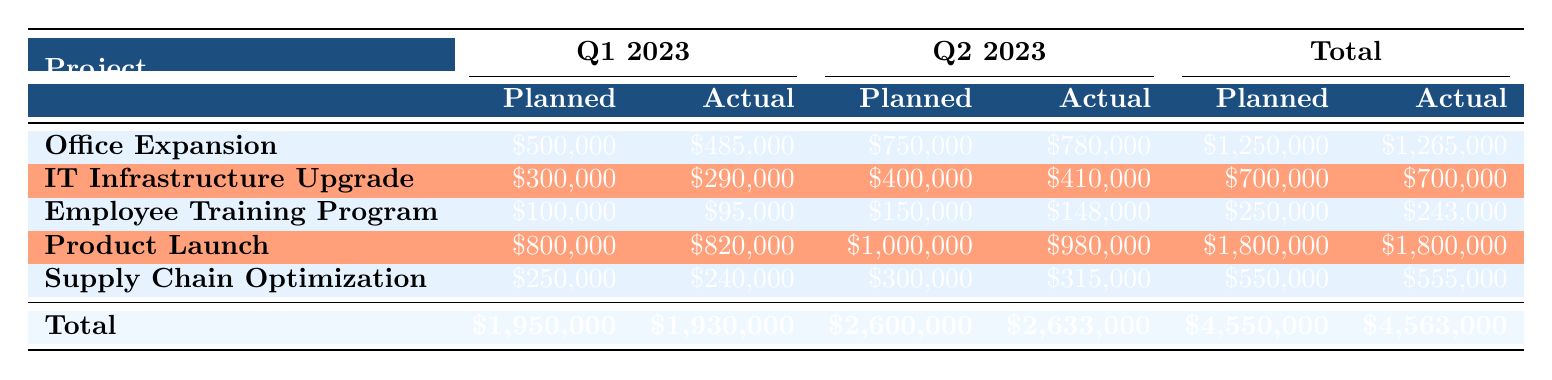What is the planned budget for the Employee Training Program in Q2 2023? The table shows the planned budget for the Employee Training Program in Q2 2023 listed under that project’s row for the respective quarter, which is 150000.
Answer: 150000 What is the actual spend for the IT Infrastructure Upgrade project in Q1 2023? The actual spend for the IT Infrastructure Upgrade project in Q1 2023 is found in its respective row and quarter, which is 290000.
Answer: 290000 Which project had the highest planned budget for Q1 2023? When reviewing the first quarter’s planned budgets across all projects, the Product Launch project shows the highest planned budget of 800000.
Answer: Product Launch What is the total actual spend across all projects in Q2 2023? By adding the actual spends for all projects in Q2 2023: 780000 (Office Expansion) + 410000 (IT Infrastructure Upgrade) + 148000 (Employee Training Program) + 980000 (Product Launch) + 315000 (Supply Chain Optimization) = 2633000.
Answer: 2633000 Does the Employee Training Program spend less than its planned budget in both quarters? In Q1 2023, the actual spend is 95000 against a planned budget of 100000 (which is less), while in Q2 2023, the actual spend is 148000 against a planned budget of 150000 (which is also less), thus confirming the statement is true.
Answer: Yes What is the variance percentage for the Office Expansion project in Q2 2023? The variance percentage for the Office Expansion project in Q2 2023 is available in the respective row for that quarter, which is -4.
Answer: -4 Which project shows a positive total variance across both quarters? The projects with positive total variances are those where the actual spends are lower than planned over the periods reviewed. By checking, the Employee Training Program and Office Expansion both exhibit positive variances.
Answer: Office Expansion, Employee Training Program What is the average variance percentage for all projects across both quarters? Adding the variance percentages: 3 (Q1 Office) + (-4) (Q2 Office) + 3.33 (Q1 IT) + (-2.5) (Q2 IT) + 5 (Q1 Training) + 1.33 (Q2 Training) + (-2.5) (Q1 Launch) + 2 (Q2 Launch) + 4 (Q1 Supply) + (-5) (Q2 Supply) gives a total of 1.16 (total of 10 entries makes the average 1.16/10).
Answer: 1.16 Which project had a negative variance in Q1 2023? Upon reviewing Q1 2023's variances, only the Product Launch displays a negative variance of -20000, indicating it exceeded its planned budget.
Answer: Product Launch 